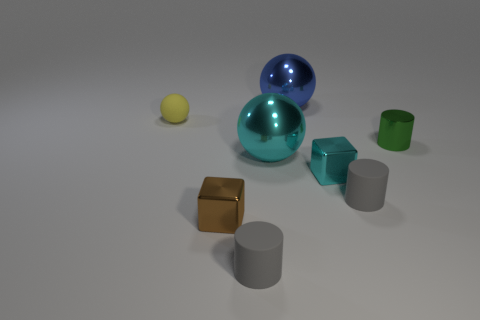What could be the purpose of this image? This image could serve various purposes such as a rendering test for 3D modeling and lighting, an illustration for material properties in an educational setting, or as a part of a visual identification game. 